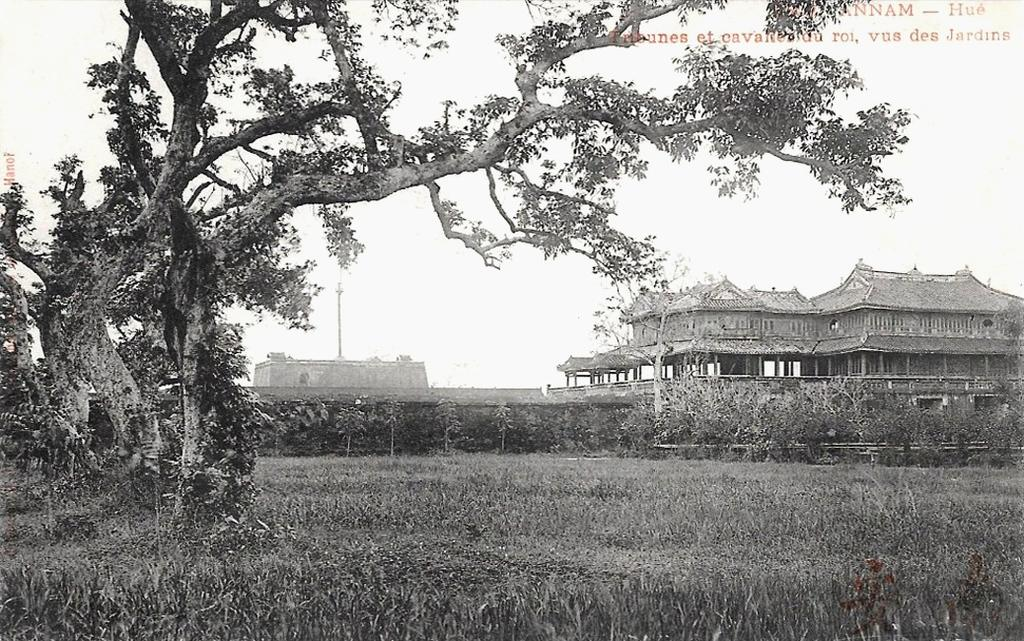What is the color scheme of the image? The image is black and white. What can be seen in the sky in the image? There is a sky in the image. What type of structures are present in the image? There are buildings in the image. What is the tall, thin object in the image? There is a pole in the image. What type of vegetation is present in the image? There are plants and trees in the image. What type of open space is visible in the image? There is a field in the image. What is the linear object in the distance in the image? There appears to be a fence in the distance. Where is the mailbox located in the image? There is no mailbox present in the image. What type of map can be seen in the image? There is no map present in the image. 